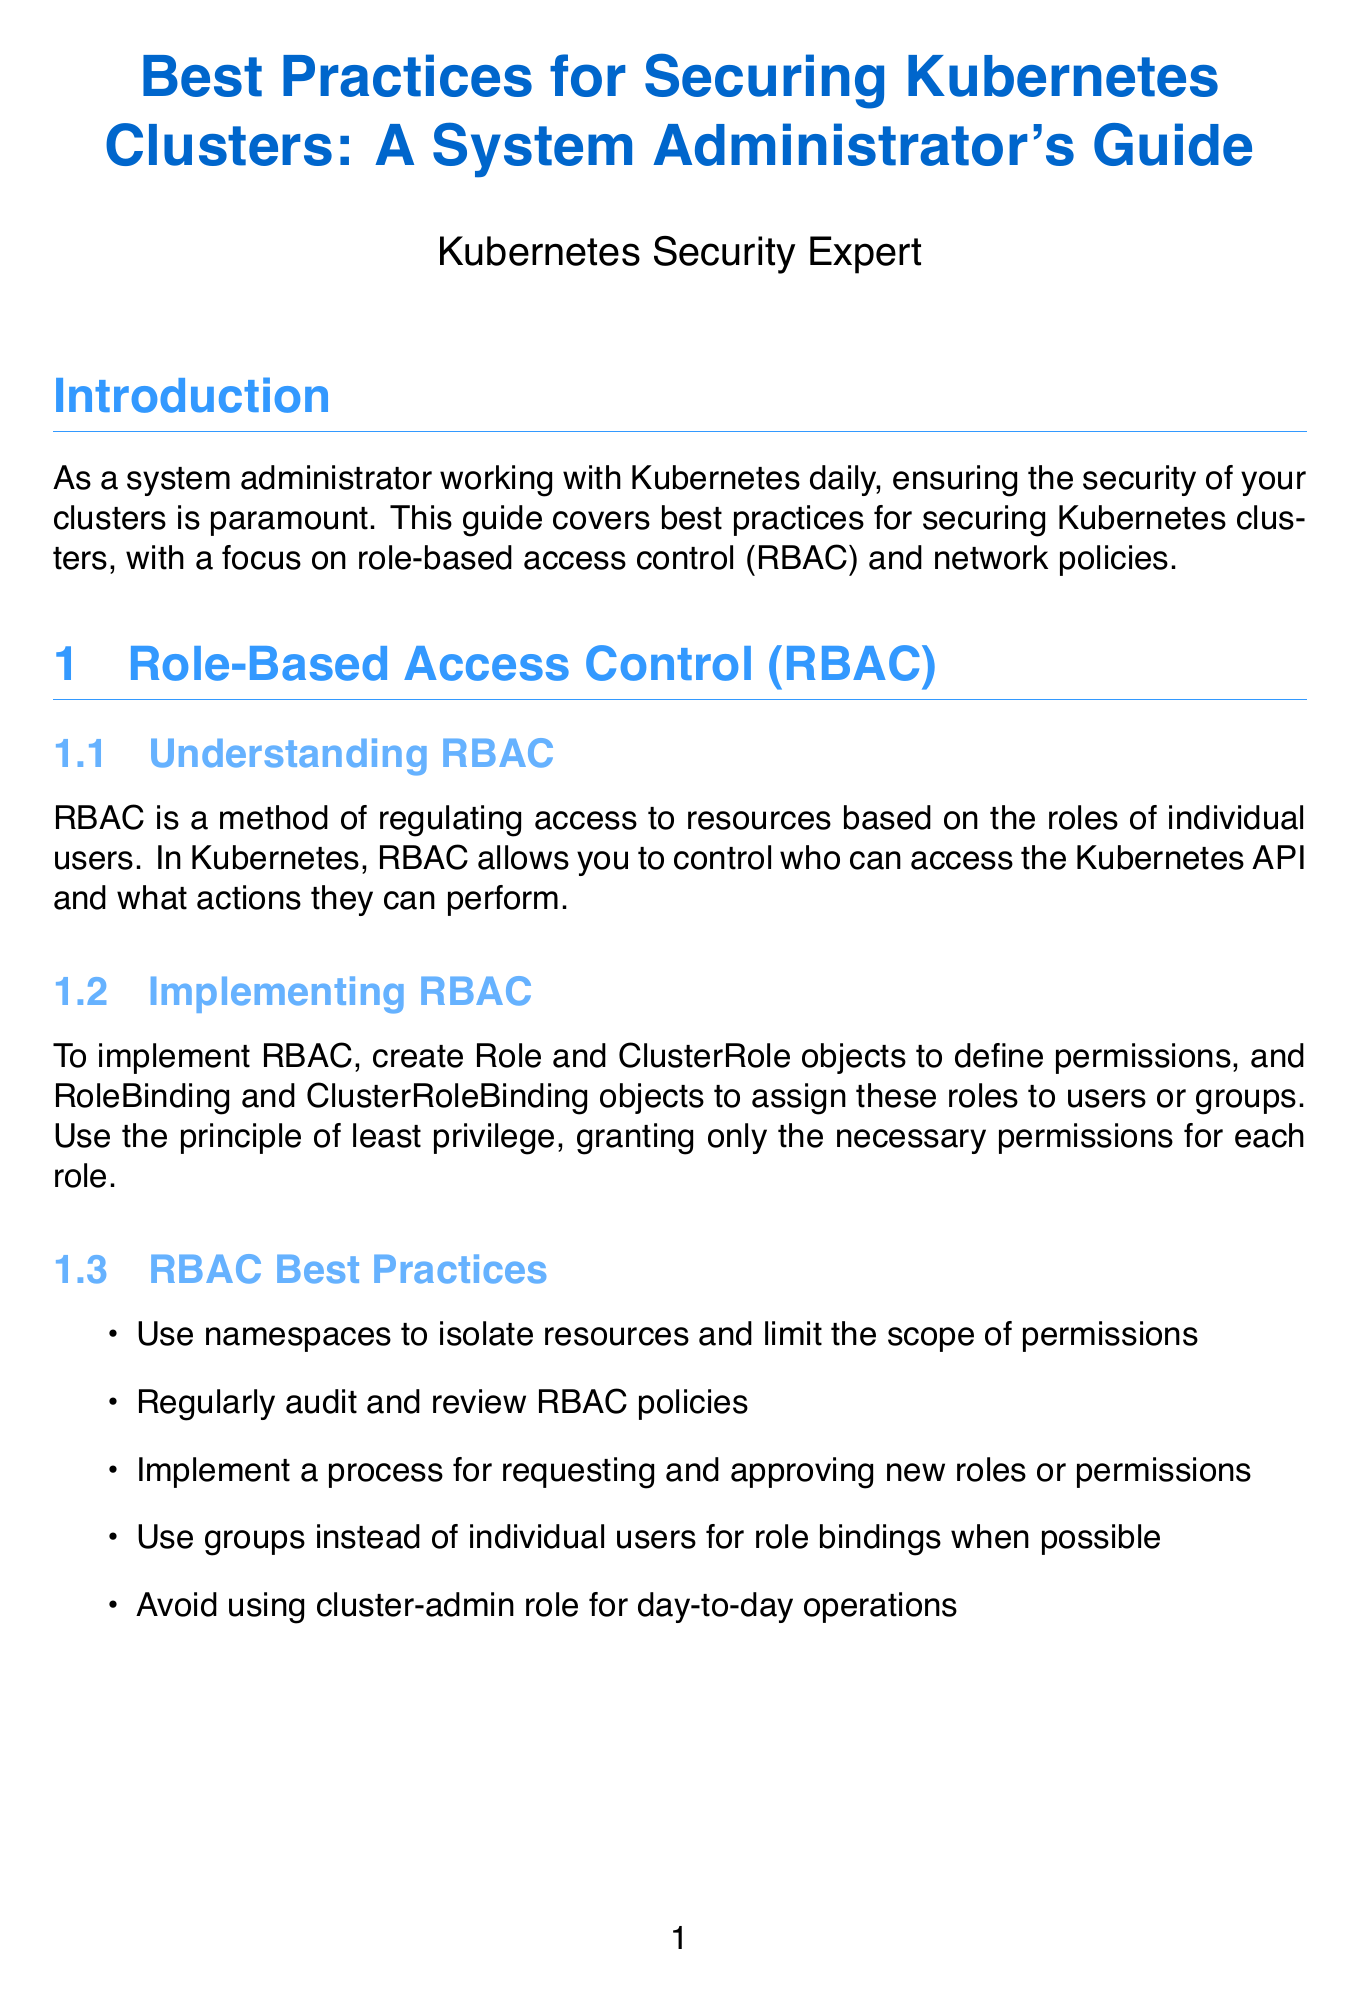What is the focus of this guide? The guide focuses on best practices for securing Kubernetes clusters, particularly role-based access control and network policies.
Answer: securing Kubernetes clusters What does RBAC stand for? The document explicitly states that RBAC stands for Role-Based Access Control.
Answer: Role-Based Access Control What is one of the RBAC best practices mentioned? The document includes multiple best practices, one of which is to regularly audit and review RBAC policies.
Answer: regularly audit and review RBAC policies Which tool is used for checking Kubernetes clusters against security best practices? The document lists kube-bench as a tool for this purpose.
Answer: kube-bench What should you implement first for network policies? The best practice suggests starting with a default deny-all policy as the initial step.
Answer: default deny-all policy How should permissions be granted according to RBAC best practices? The principle of least privilege should be followed when granting permissions.
Answer: principle of least privilege Which component is crucial for implementing egress policies? The egress policies require the Container Network Interface plugin to be supportive of network policies.
Answer: Container Network Interface plugin How often should Kubernetes and its components be updated? The document advises to regularly update and patch Kubernetes and all components.
Answer: regularly What should be used for managing sensitive information in Kubernetes? The document recommends using Kubernetes Secrets for this purpose.
Answer: Kubernetes Secrets 